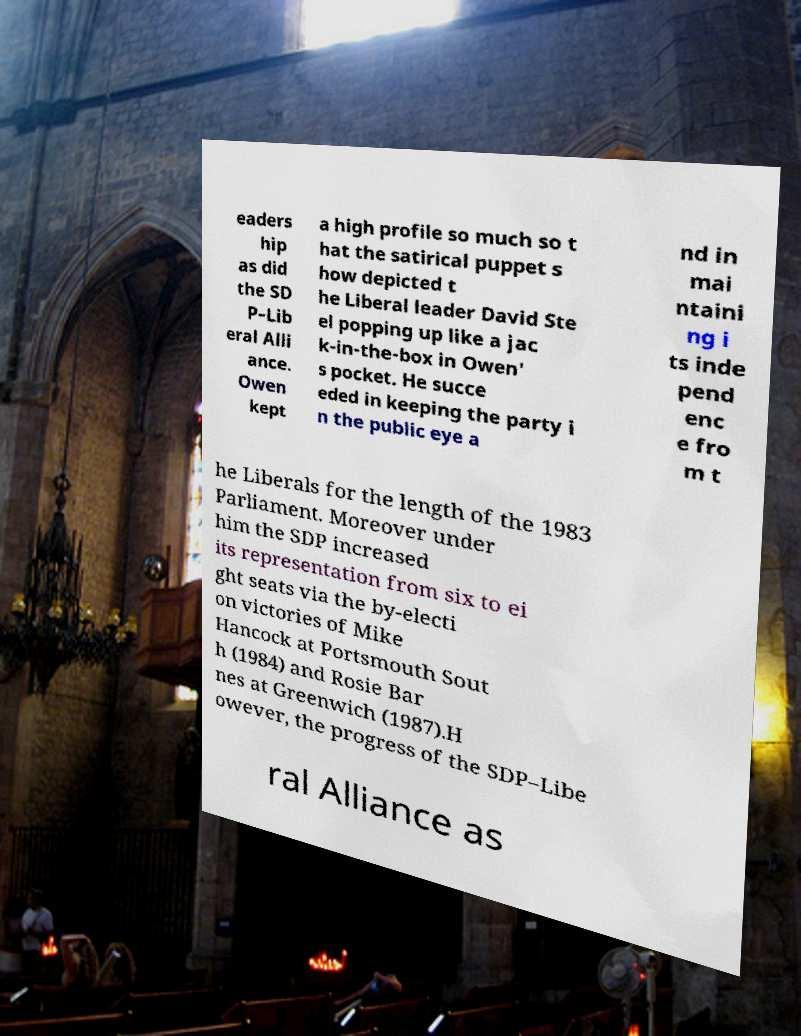Please read and relay the text visible in this image. What does it say? eaders hip as did the SD P–Lib eral Alli ance. Owen kept a high profile so much so t hat the satirical puppet s how depicted t he Liberal leader David Ste el popping up like a jac k-in-the-box in Owen' s pocket. He succe eded in keeping the party i n the public eye a nd in mai ntaini ng i ts inde pend enc e fro m t he Liberals for the length of the 1983 Parliament. Moreover under him the SDP increased its representation from six to ei ght seats via the by-electi on victories of Mike Hancock at Portsmouth Sout h (1984) and Rosie Bar nes at Greenwich (1987).H owever, the progress of the SDP–Libe ral Alliance as 